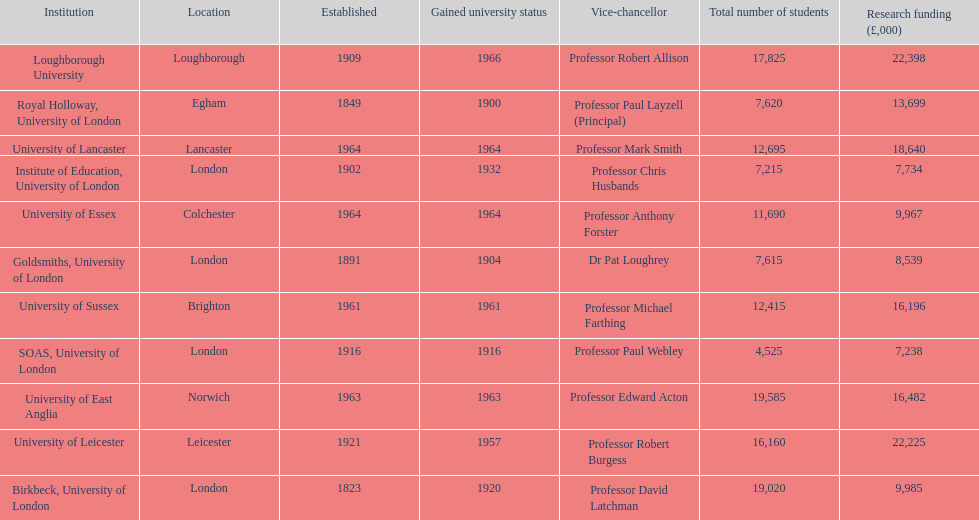Which institution has the most research funding? Loughborough University. 